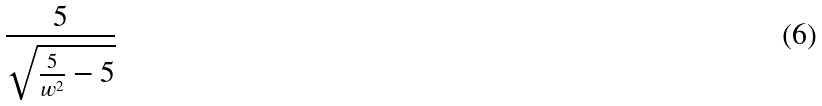<formula> <loc_0><loc_0><loc_500><loc_500>\frac { 5 } { \sqrt { \frac { 5 } { w ^ { 2 } } - 5 } }</formula> 